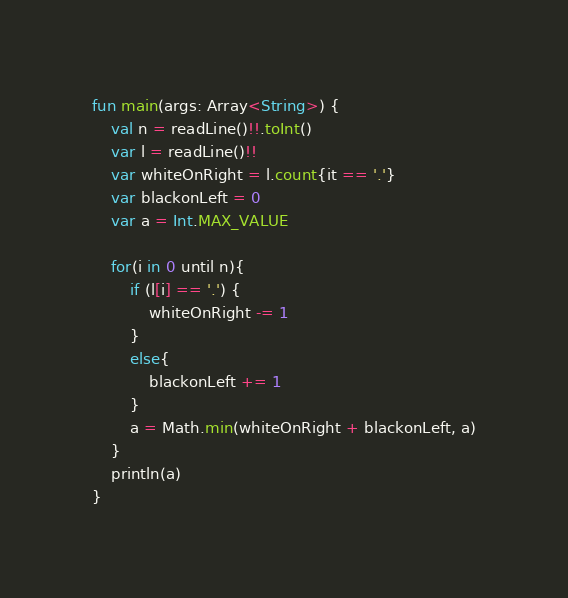Convert code to text. <code><loc_0><loc_0><loc_500><loc_500><_Kotlin_>fun main(args: Array<String>) {
    val n = readLine()!!.toInt()
    var l = readLine()!!
    var whiteOnRight = l.count{it == '.'}
    var blackonLeft = 0
    var a = Int.MAX_VALUE

    for(i in 0 until n){
        if (l[i] == '.') {
            whiteOnRight -= 1
        }
        else{
            blackonLeft += 1
        }
        a = Math.min(whiteOnRight + blackonLeft, a)
    }
    println(a)
}</code> 